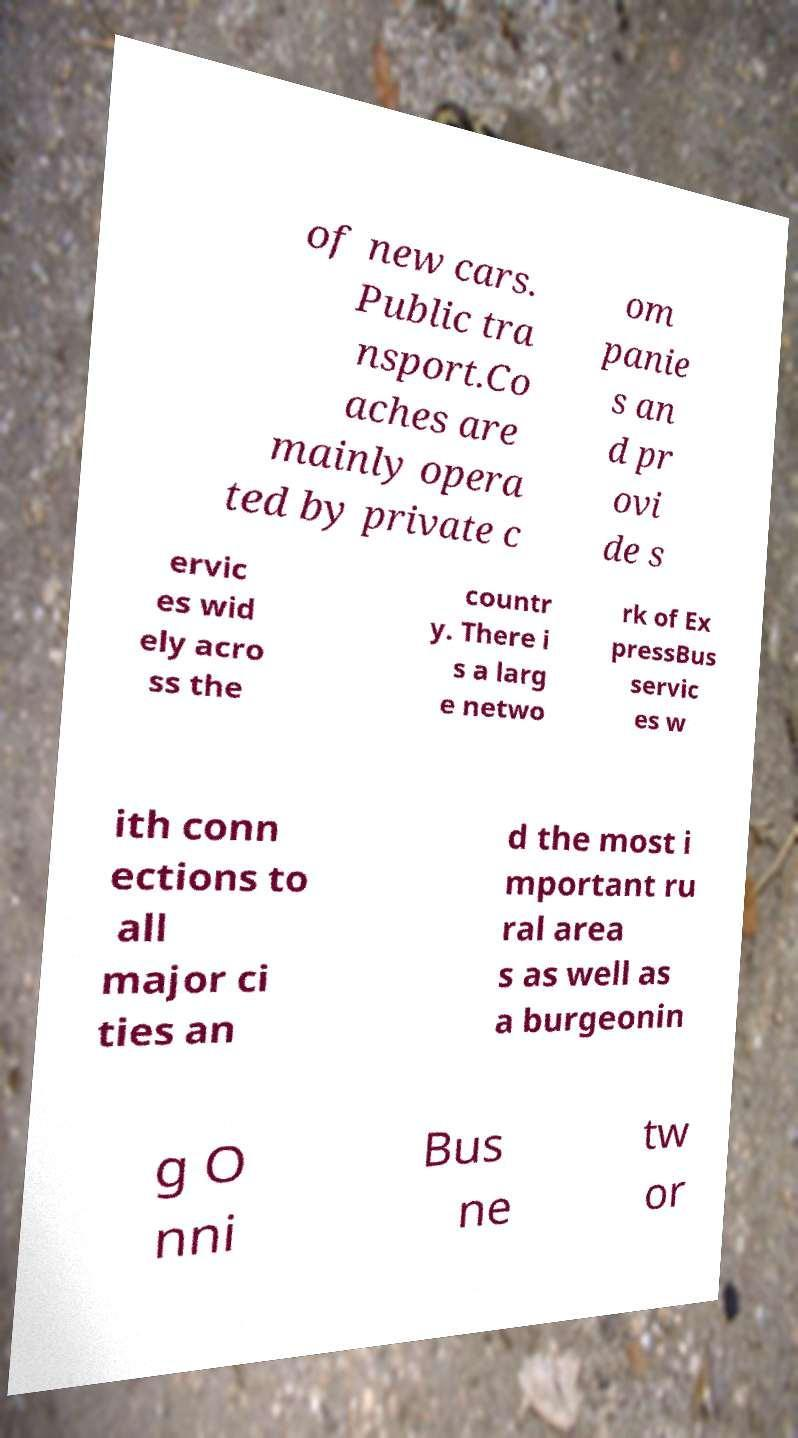What messages or text are displayed in this image? I need them in a readable, typed format. of new cars. Public tra nsport.Co aches are mainly opera ted by private c om panie s an d pr ovi de s ervic es wid ely acro ss the countr y. There i s a larg e netwo rk of Ex pressBus servic es w ith conn ections to all major ci ties an d the most i mportant ru ral area s as well as a burgeonin g O nni Bus ne tw or 